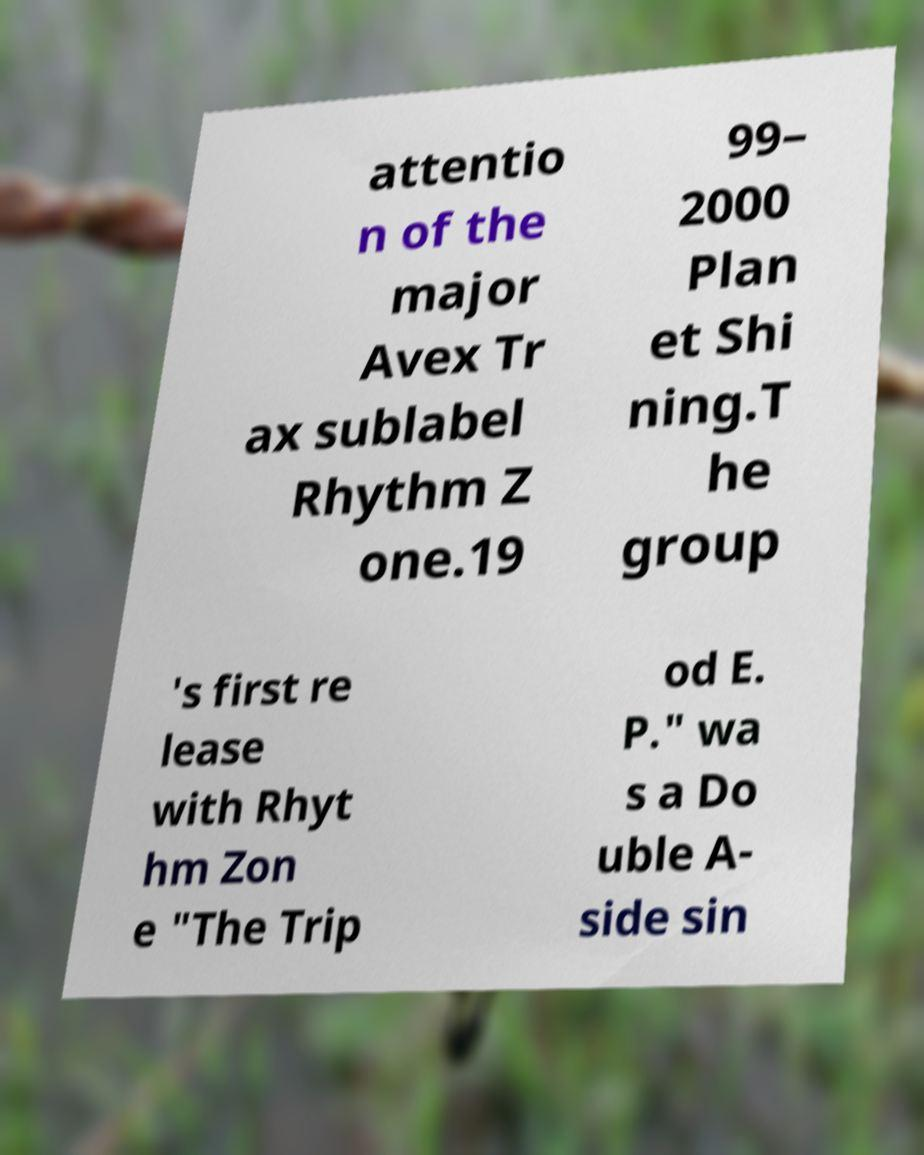What messages or text are displayed in this image? I need them in a readable, typed format. attentio n of the major Avex Tr ax sublabel Rhythm Z one.19 99– 2000 Plan et Shi ning.T he group 's first re lease with Rhyt hm Zon e "The Trip od E. P." wa s a Do uble A- side sin 